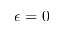Convert formula to latex. <formula><loc_0><loc_0><loc_500><loc_500>\epsilon = 0</formula> 